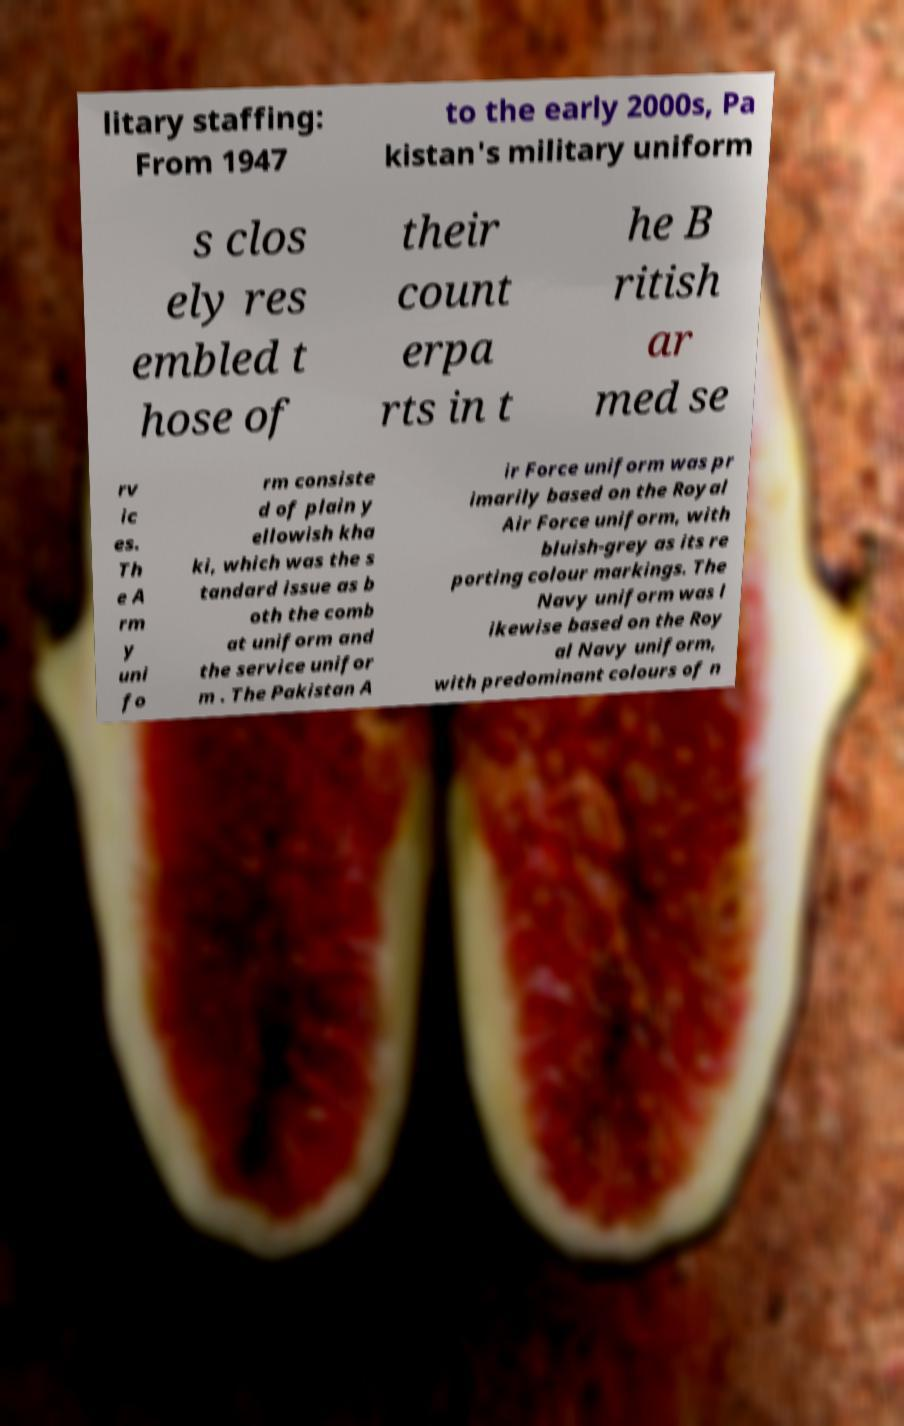Can you read and provide the text displayed in the image?This photo seems to have some interesting text. Can you extract and type it out for me? litary staffing: From 1947 to the early 2000s, Pa kistan's military uniform s clos ely res embled t hose of their count erpa rts in t he B ritish ar med se rv ic es. Th e A rm y uni fo rm consiste d of plain y ellowish kha ki, which was the s tandard issue as b oth the comb at uniform and the service unifor m . The Pakistan A ir Force uniform was pr imarily based on the Royal Air Force uniform, with bluish-grey as its re porting colour markings. The Navy uniform was l ikewise based on the Roy al Navy uniform, with predominant colours of n 